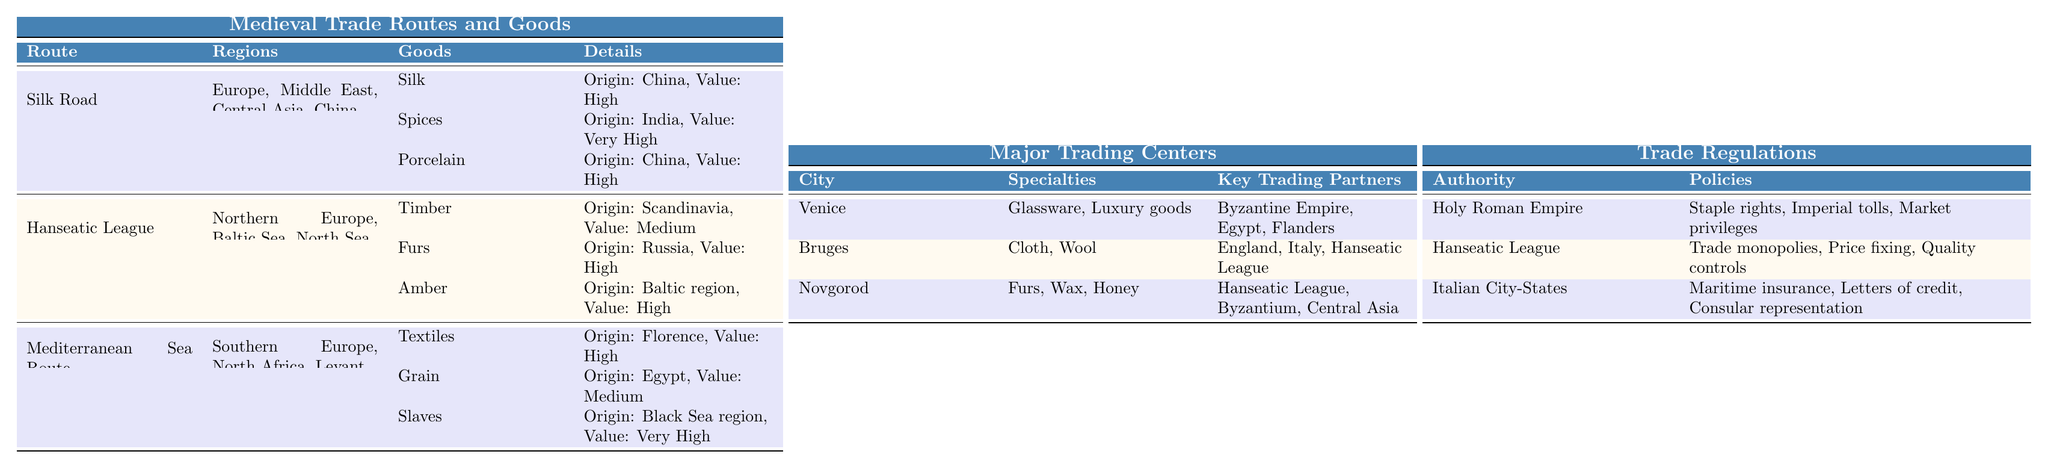What are the main regions connected by the Silk Road? The table lists the main regions connected by the Silk Road as Europe, Middle East, Central Asia, and China.
Answer: Europe, Middle East, Central Asia, China Which goods exchanged along the Hanseatic League originate from Scandinavia? The table specifies that the good originating from Scandinavia along the Hanseatic League is Timber, which has a medium value.
Answer: Timber Is it true that Grain is among the goods traded along the Mediterranean Sea Route? The table confirms that Grain is listed as one of the goods traded along the Mediterranean Sea Route.
Answer: Yes Which trading center specializes in Furs and who are its key trading partners? According to the table, Novgorod specializes in Furs and has key trading partners that include the Hanseatic League, Byzantium, and Central Asia.
Answer: Novgorod; Hanseatic League, Byzantium, Central Asia What is the value of Spices traded on the Silk Road? The table states that the value of Spices traded on the Silk Road is categorized as very high.
Answer: Very High How many main regions are associated with the Mediterranean Sea Route? The table lists three main regions for the Mediterranean Sea Route: Southern Europe, North Africa, and Levant. Therefore, there are three regions associated with this route.
Answer: Three What is the origin of Porcelain and which regions are its primary consumers? The table indicates that Porcelain originates from China and its primary consumers are Persia and Egypt.
Answer: China; Persia, Egypt What are the three policies enforced by the Hanseatic League? The table specifies that the three policies enforced by the Hanseatic League are trade monopolies, price fixing, and quality controls.
Answer: Trade monopolies, price fixing, quality controls Which good from the Silk Road has the highest value and where does it originate? The table shows that Spices have the highest value (very high) and originate from India, making it the good with the highest value along the Silk Road.
Answer: Spices; India How do the origins of goods differ between the Silk Road and the Hanseatic League? Examining the table, the Silk Road has goods originating from China and India (Silk, Spices) while the Hanseatic League has goods originating from Scandinavia and Russia (Timber, Furs). This shows a geographical distinction in the sources of traded goods.
Answer: Silk Road: China, India; Hanseatic League: Scandinavia, Russia 